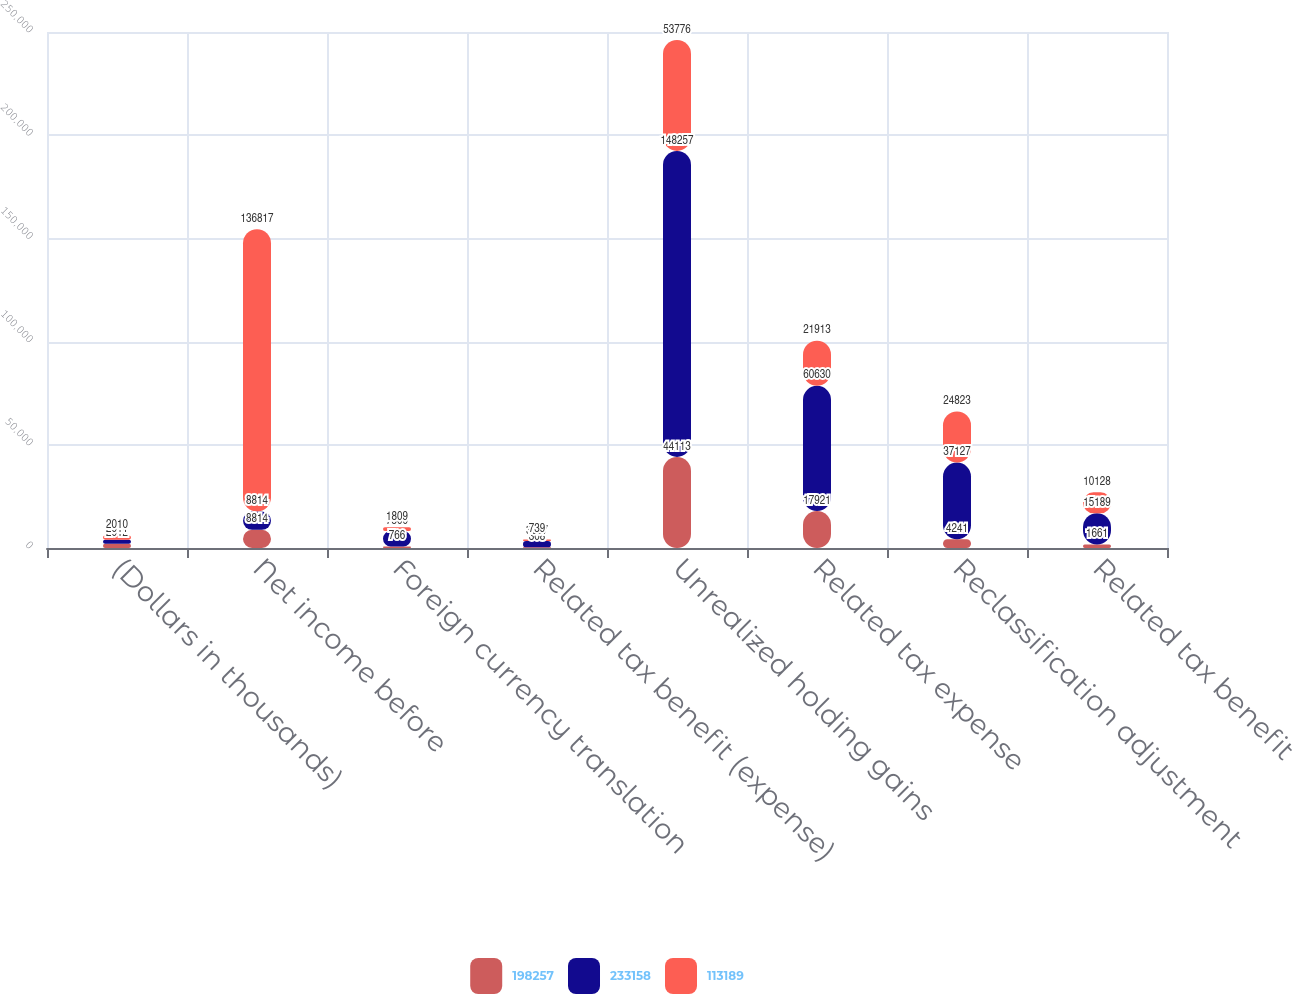Convert chart. <chart><loc_0><loc_0><loc_500><loc_500><stacked_bar_chart><ecel><fcel>(Dollars in thousands)<fcel>Net income before<fcel>Foreign currency translation<fcel>Related tax benefit (expense)<fcel>Unrealized holding gains<fcel>Related tax expense<fcel>Reclassification adjustment<fcel>Related tax benefit<nl><fcel>198257<fcel>2012<fcel>8814<fcel>766<fcel>308<fcel>44113<fcel>17921<fcel>4241<fcel>1661<nl><fcel>233158<fcel>2011<fcel>8814<fcel>7500<fcel>3067<fcel>148257<fcel>60630<fcel>37127<fcel>15189<nl><fcel>113189<fcel>2010<fcel>136817<fcel>1809<fcel>739<fcel>53776<fcel>21913<fcel>24823<fcel>10128<nl></chart> 